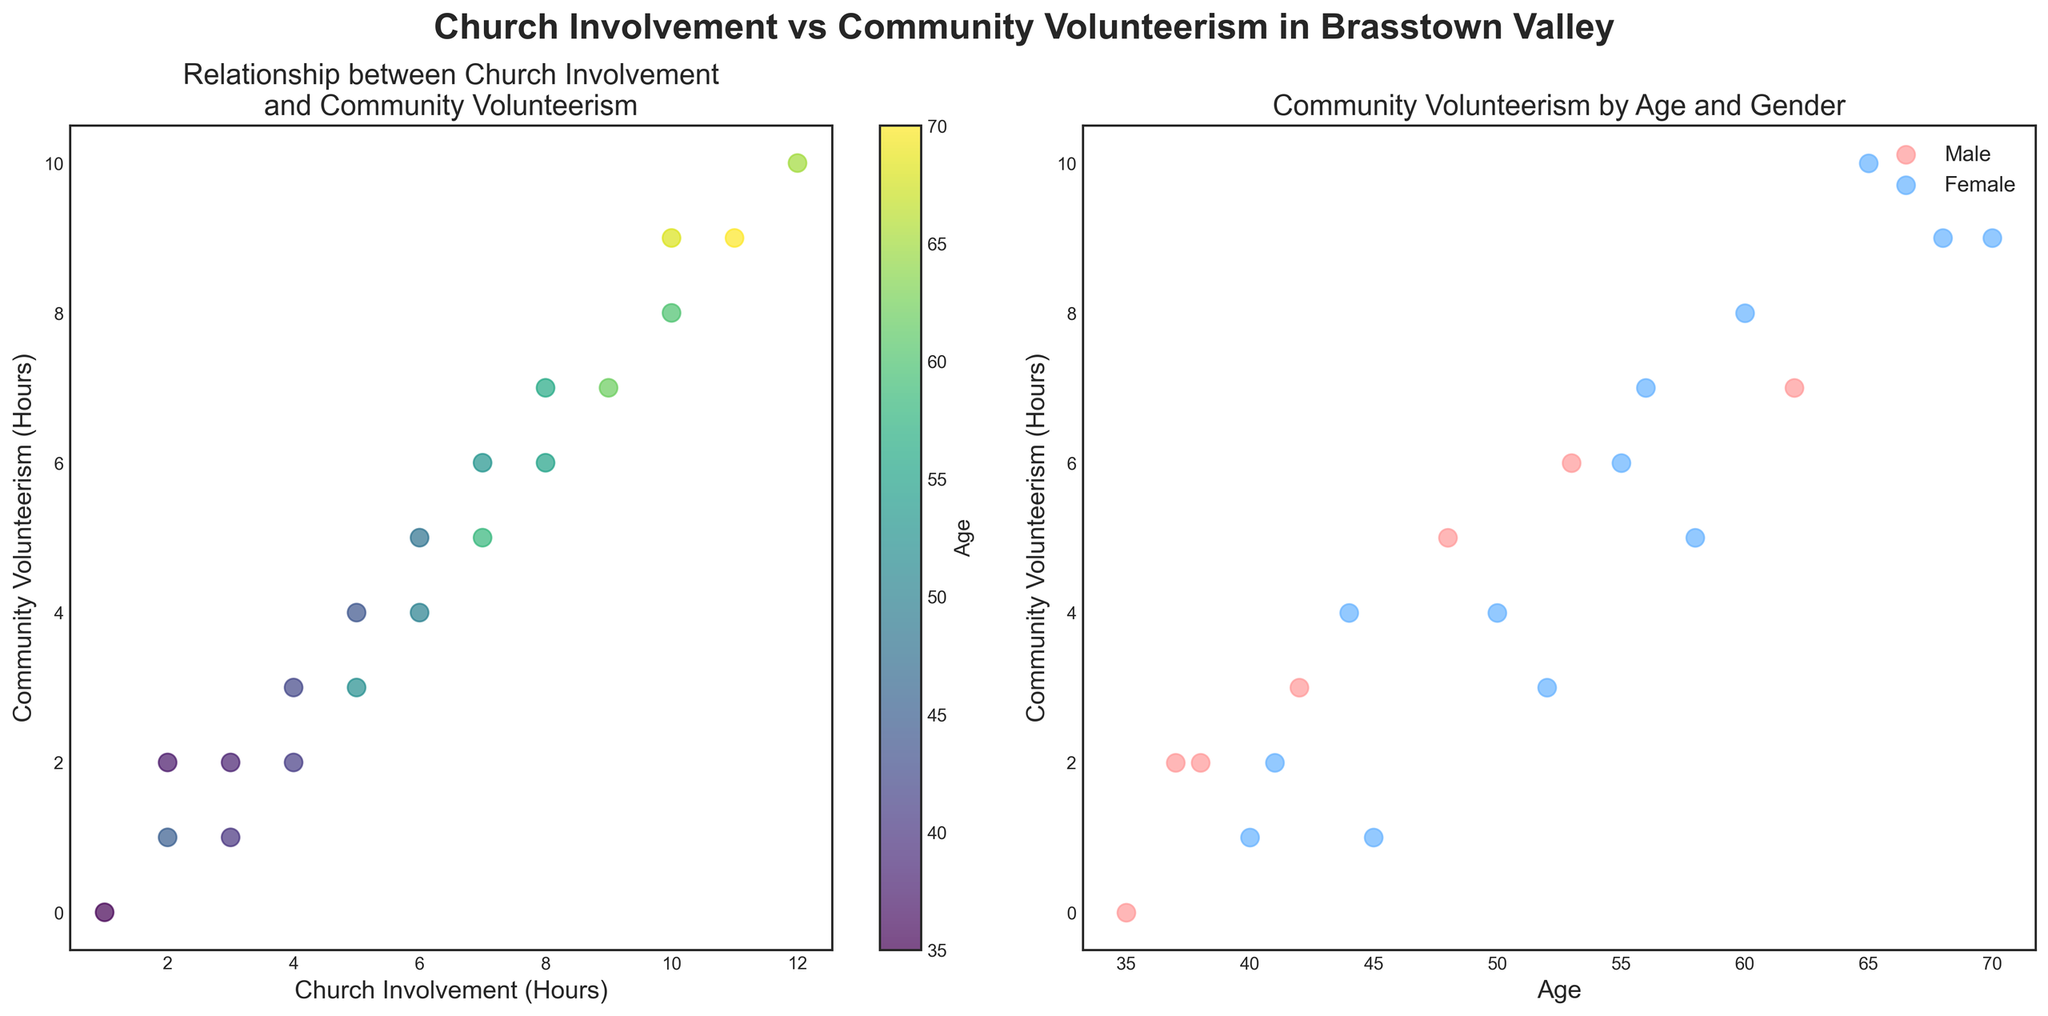What is the title of the first scatter plot? The title is located at the top of the plot area. It reads "Relationship between Church Involvement and Community Volunteerism".
Answer: Relationship between Church Involvement and Community Volunteerism How many hours of church involvement correspond to 10 hours of community volunteerism? By examining the first scatter plot, you can find the point that aligns with 10 hours on the y-axis. The corresponding x-axis value shows 12 hours of church involvement.
Answer: 12 Which gender has more data points in the second scatter plot? Count the number of points for each color representing different genders. The second scatter plot shows that there are more blue points, which represent females.
Answer: Female What is the color used to indicate age in the first scatter plot? In the first scatter plot, the color bar next to it uses a gradient from light to dark colors in the 'viridis' palette to indicate age differences.
Answer: Viridis gradient Is there a trend visible between church involvement and community volunteerism hours in the first plot? Observing the first scatter plot, there seems to be an upward trend as points generally move from the bottom left to the top right. This suggests a positive relationship between church involvement and community volunteerism hours.
Answer: Yes What is the maximum number of community volunteerism hours observed for any gender in the second scatter plot? Look at the y-axis of the second scatter plot and find the highest value point for either gender. The highest number shown is 10 hours.
Answer: 10 Which age group shows the highest community volunteerism in the first scatter plot? Locate the data point with the highest y-value (10 hours) and check its corresponding color representing age in the color bar. The point is dark green, indicating an age around 65.
Answer: 65 Are males more involved in community volunteerism as they get older based on the second scatter plot? By analyzing the trend of red points in the second scatter plot, we can observe that as the age on the x-axis increases, the y-axis values (volunteerism hours) generally increase for males.
Answer: Yes What is the relationship between community volunteerism and age for females in the second scatter plot? The trend of blue points in the second scatter plot shows an increase in community volunteerism hours as age increases, indicating a positive relationship.
Answer: Positive 